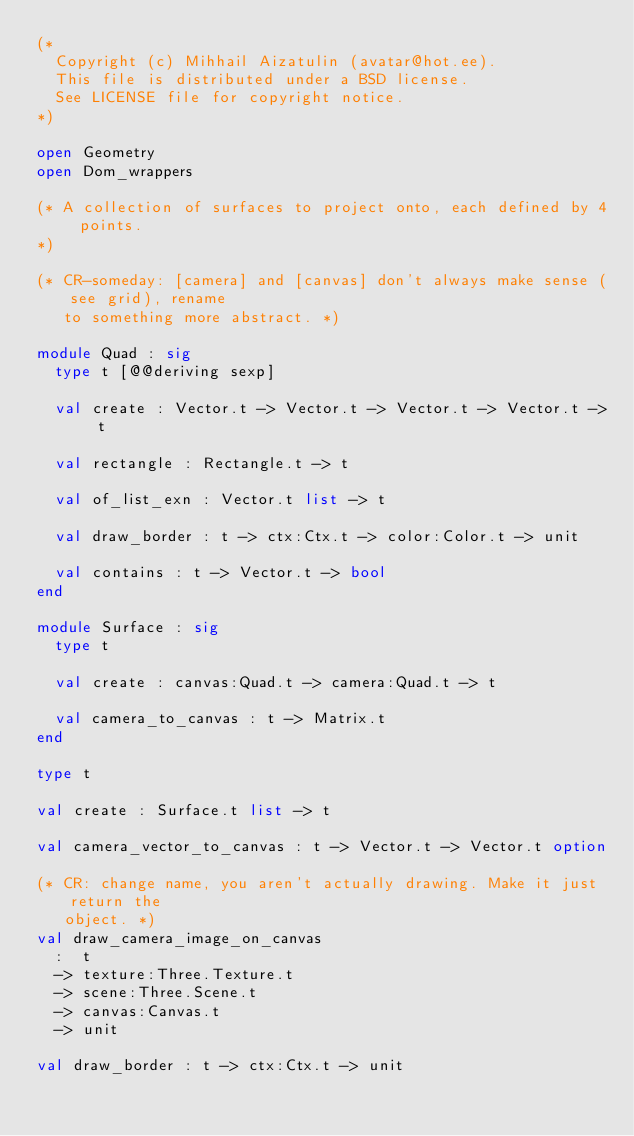Convert code to text. <code><loc_0><loc_0><loc_500><loc_500><_OCaml_>(*
  Copyright (c) Mihhail Aizatulin (avatar@hot.ee).
  This file is distributed under a BSD license.
  See LICENSE file for copyright notice.
*)

open Geometry
open Dom_wrappers

(* A collection of surfaces to project onto, each defined by 4 points.
*)

(* CR-someday: [camera] and [canvas] don't always make sense (see grid), rename
   to something more abstract. *)

module Quad : sig
  type t [@@deriving sexp]

  val create : Vector.t -> Vector.t -> Vector.t -> Vector.t -> t

  val rectangle : Rectangle.t -> t

  val of_list_exn : Vector.t list -> t

  val draw_border : t -> ctx:Ctx.t -> color:Color.t -> unit

  val contains : t -> Vector.t -> bool
end

module Surface : sig
  type t

  val create : canvas:Quad.t -> camera:Quad.t -> t

  val camera_to_canvas : t -> Matrix.t
end

type t

val create : Surface.t list -> t

val camera_vector_to_canvas : t -> Vector.t -> Vector.t option

(* CR: change name, you aren't actually drawing. Make it just return the
   object. *)
val draw_camera_image_on_canvas
  :  t
  -> texture:Three.Texture.t
  -> scene:Three.Scene.t
  -> canvas:Canvas.t
  -> unit

val draw_border : t -> ctx:Ctx.t -> unit
</code> 